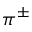<formula> <loc_0><loc_0><loc_500><loc_500>\pi ^ { \pm }</formula> 